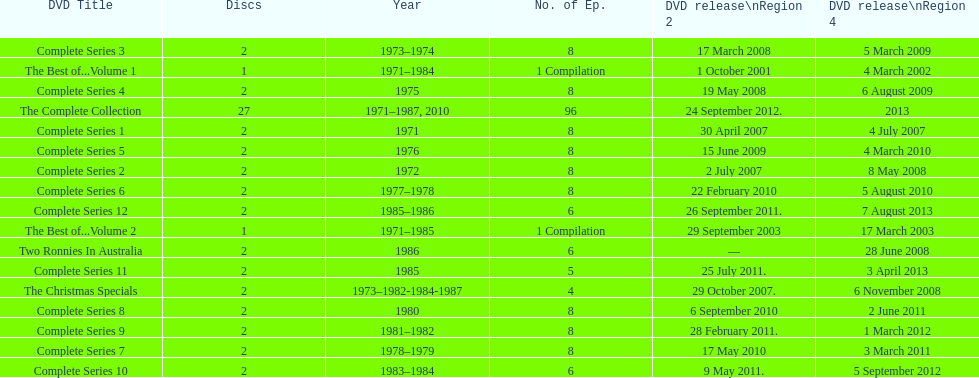The entire series consists of 96 episodes, so how many episodes are there in just the christmas specials? 4. 